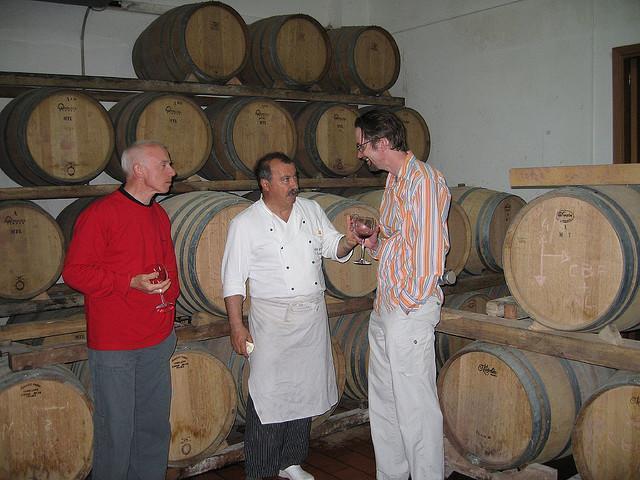What is contained inside the brown barrels?
Make your selection from the four choices given to correctly answer the question.
Options: Soy sauce, water, beer, wine. Wine. 